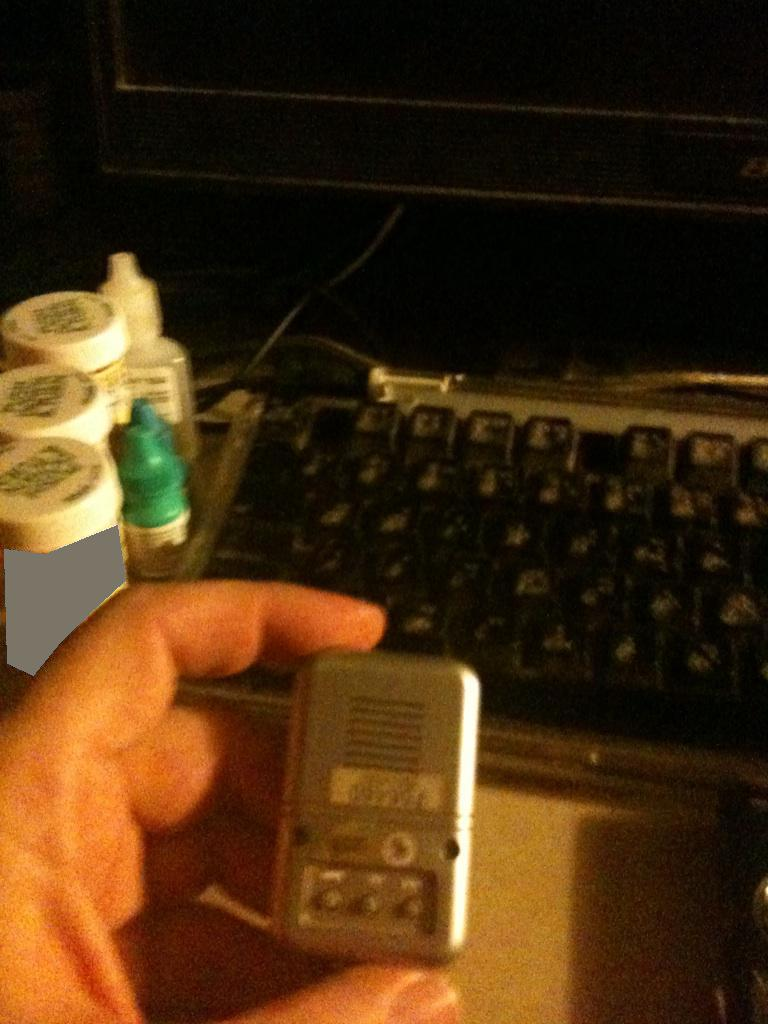Imagine this setup in a futuristic context. How might these objects be different? In a futuristic context, the keyboard might be replaced by a holographic input device, allowing for typing in mid-air without physical keys. The small containers could be advanced medical devices that automatically dispense medication based on biometric readings. The electronic device in the hand might be an advanced multi-functional gadget, integrating numerous technologies such as augmented reality interfaces, health monitoring, and communication functions all in a compact form. Can you give a detailed description of the futuristic electronic device and its functionalities? Certainly! The futuristic electronic device is a sleek, compact gadget that fits comfortably in the palm of your hand. It's equipped with a high-resolution display that can extend into a holographic projector for a larger, more interactive screen. It features biometric sensors that constantly monitor the user's vital signs, such as heart rate, blood pressure, and hydration levels. The device can connect to various smart systems in the environment, allowing it to control home automation systems, vehicles, and other electronics remotely. With built-in AI, it can assist with daily tasks, schedule management, and provide real-time translations for different languages. Its augmented reality capabilities allow the user to overlay digital information onto the real world, providing enhanced navigation, information about the surroundings, and entertainment experiences. Additionally, it's equipped with advanced communication tools, enabling high-definition video calls, instant messaging, and secure data transfer. 